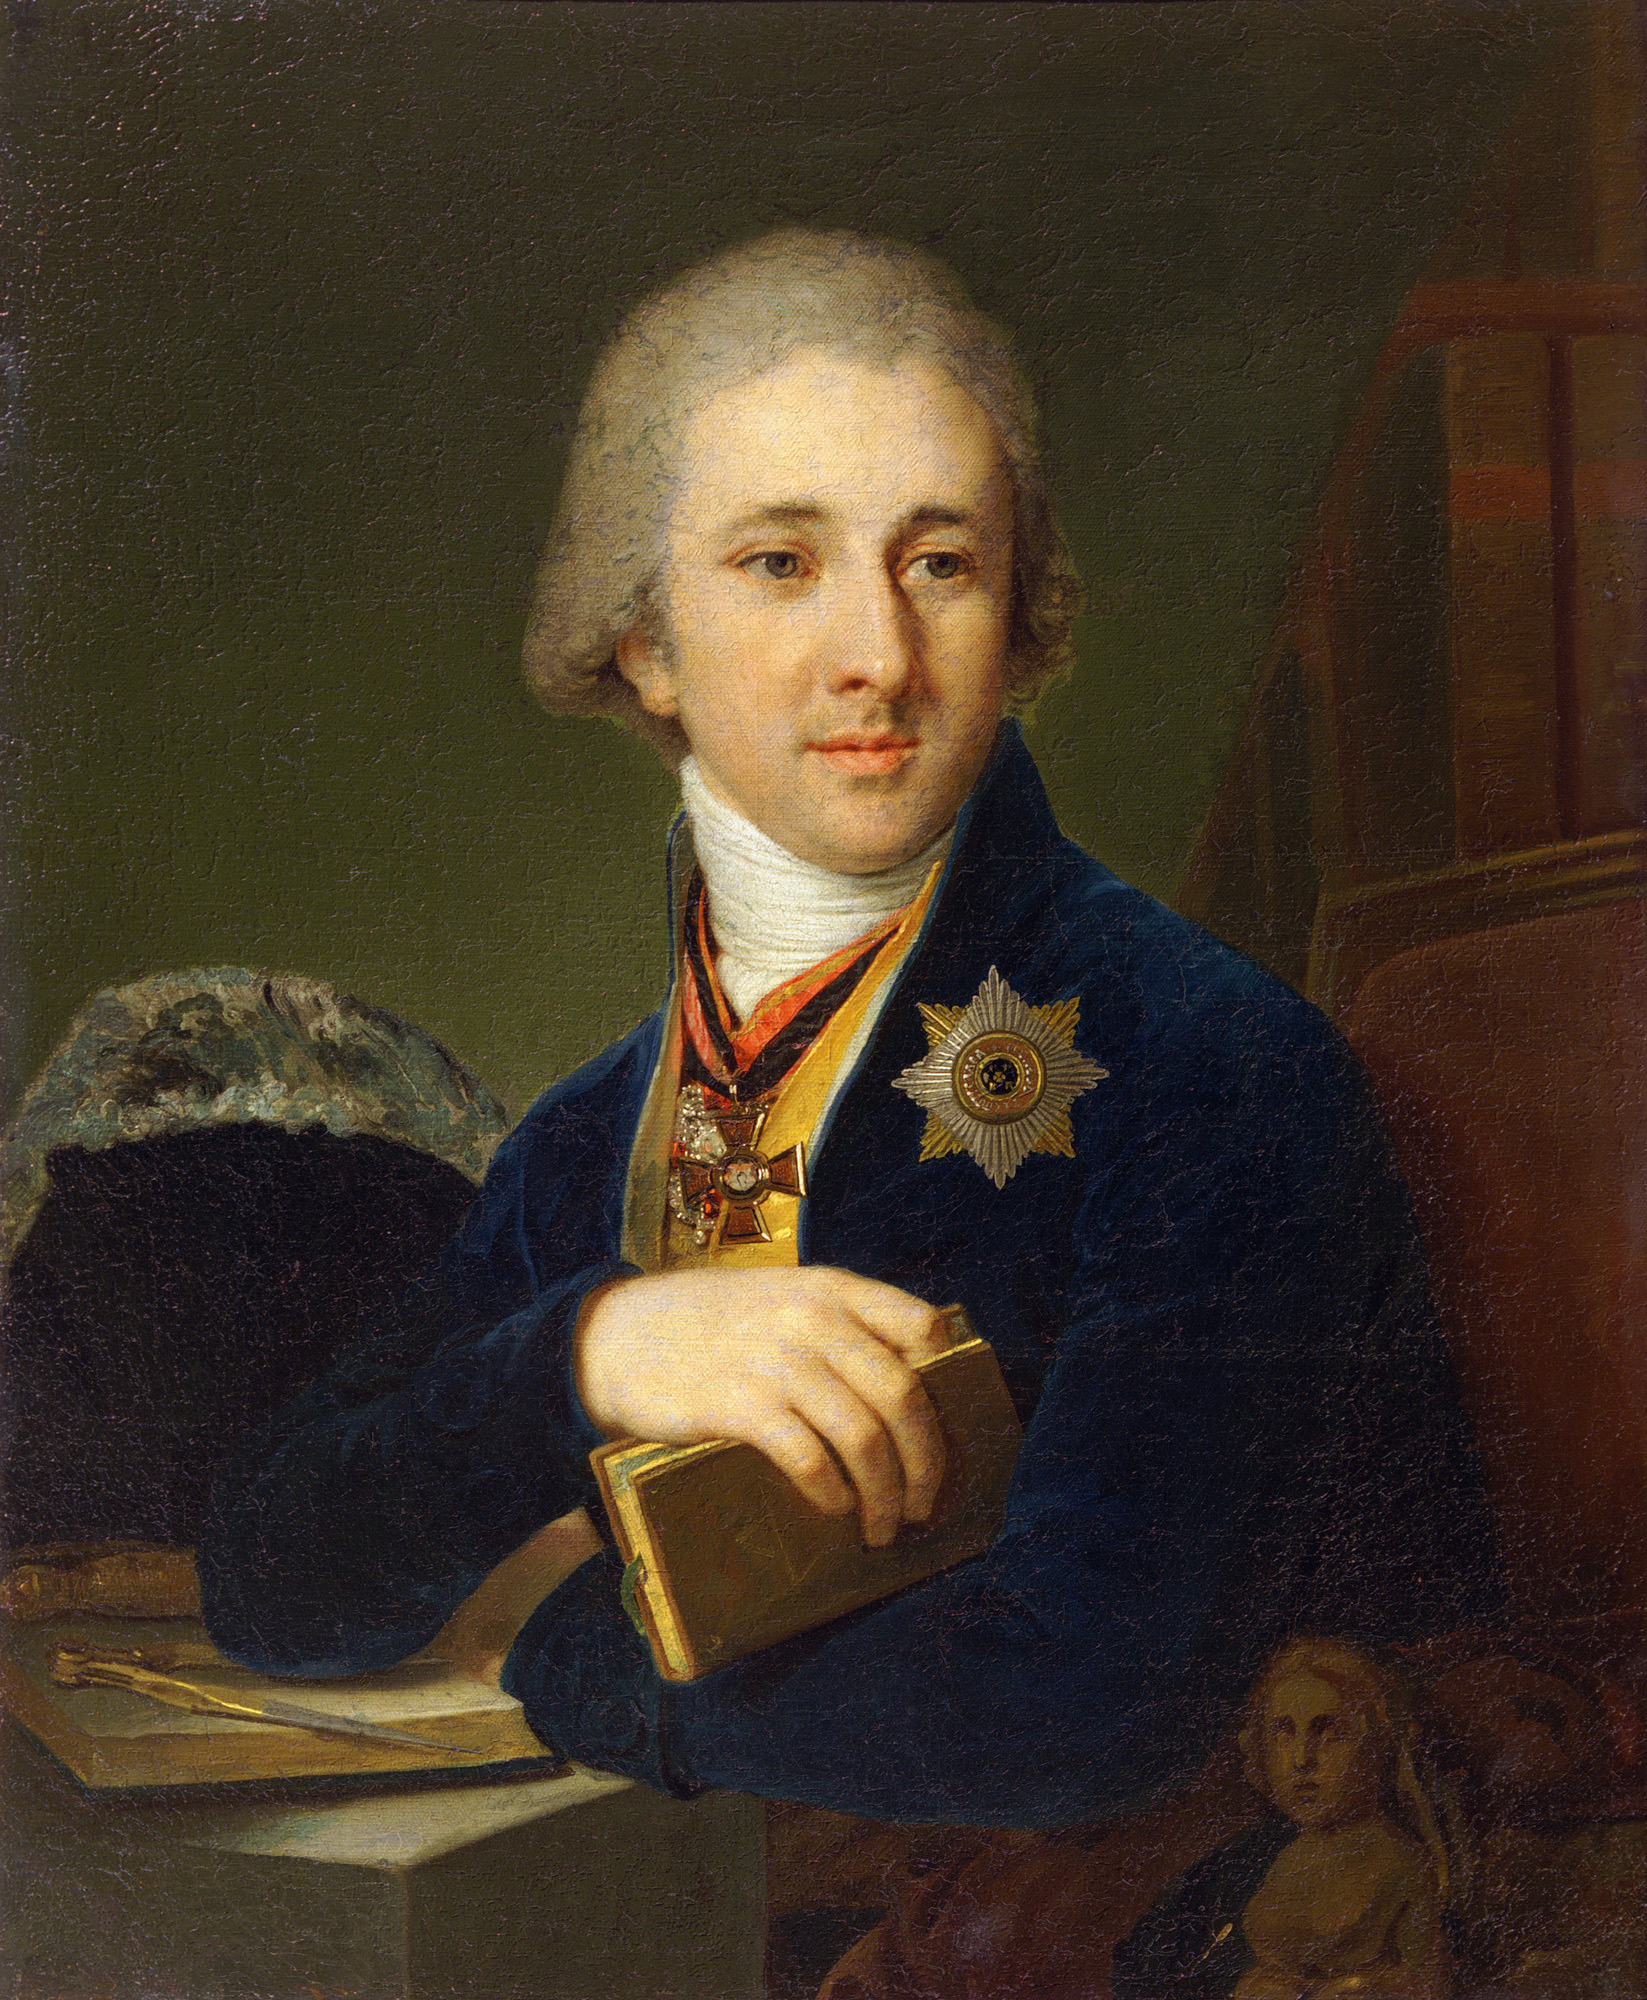What can you infer about the artist’s technique in this painting? The artist employs a realistic style, capturing meticulous details that convey the texture of the fabric, the shine on the medals, and the lifelike appearance of the subject. The use of lighting focuses on the face and upper torso, drawing attention to the subject's expression and the symbols of his status. This technique, combined with the detailed and balanced background, highlights the artist's skill in portraiture, likely intended to emphasize the subject's significance and persona. What does the painting in the background add to the overall composition? The inclusion of a second painting within this portrait adds a layer of depth and narrative to the composition. It suggests a connection between the subject and the female figure depicted, possibly hinting at family ties, personal ideals, or influential women in his life. Artistically, it enriches the scene, providing a contrast to the foreground and augmenting the storytelling aspect of the portrait. 